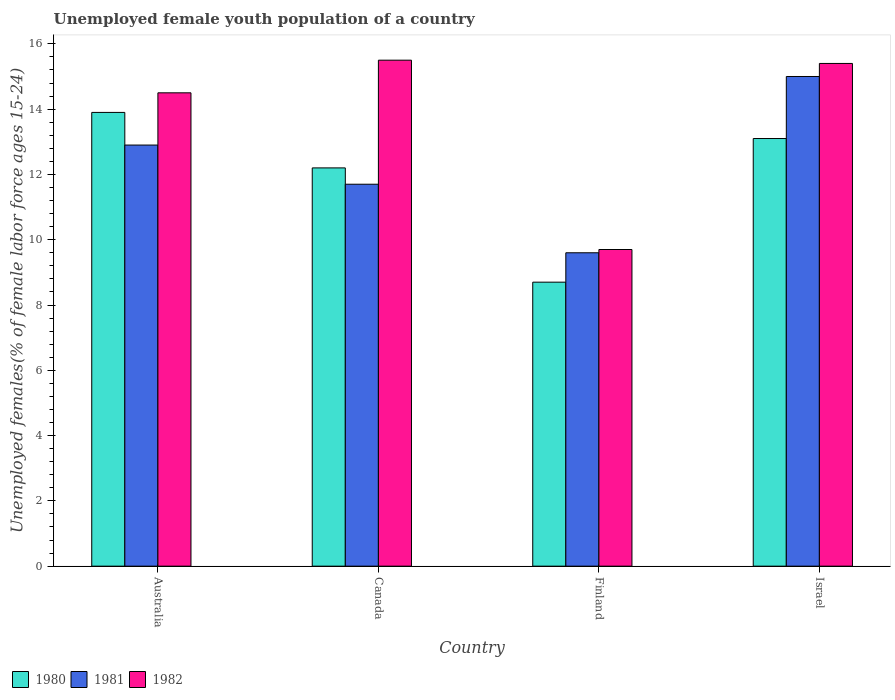How many different coloured bars are there?
Keep it short and to the point. 3. Are the number of bars per tick equal to the number of legend labels?
Provide a short and direct response. Yes. Are the number of bars on each tick of the X-axis equal?
Offer a terse response. Yes. How many bars are there on the 3rd tick from the right?
Keep it short and to the point. 3. Across all countries, what is the maximum percentage of unemployed female youth population in 1981?
Provide a short and direct response. 15. Across all countries, what is the minimum percentage of unemployed female youth population in 1981?
Provide a short and direct response. 9.6. In which country was the percentage of unemployed female youth population in 1981 maximum?
Provide a succinct answer. Israel. In which country was the percentage of unemployed female youth population in 1981 minimum?
Keep it short and to the point. Finland. What is the total percentage of unemployed female youth population in 1980 in the graph?
Offer a very short reply. 47.9. What is the difference between the percentage of unemployed female youth population in 1982 in Canada and that in Finland?
Offer a terse response. 5.8. What is the difference between the percentage of unemployed female youth population in 1980 in Israel and the percentage of unemployed female youth population in 1982 in Canada?
Keep it short and to the point. -2.4. What is the average percentage of unemployed female youth population in 1981 per country?
Keep it short and to the point. 12.3. What is the difference between the percentage of unemployed female youth population of/in 1980 and percentage of unemployed female youth population of/in 1981 in Finland?
Offer a very short reply. -0.9. In how many countries, is the percentage of unemployed female youth population in 1982 greater than 3.2 %?
Provide a succinct answer. 4. What is the ratio of the percentage of unemployed female youth population in 1981 in Finland to that in Israel?
Your answer should be compact. 0.64. What is the difference between the highest and the second highest percentage of unemployed female youth population in 1980?
Ensure brevity in your answer.  0.9. What is the difference between the highest and the lowest percentage of unemployed female youth population in 1981?
Offer a terse response. 5.4. What does the 2nd bar from the left in Canada represents?
Offer a very short reply. 1981. Is it the case that in every country, the sum of the percentage of unemployed female youth population in 1981 and percentage of unemployed female youth population in 1980 is greater than the percentage of unemployed female youth population in 1982?
Offer a terse response. Yes. How many countries are there in the graph?
Provide a succinct answer. 4. What is the difference between two consecutive major ticks on the Y-axis?
Offer a very short reply. 2. Does the graph contain grids?
Offer a very short reply. No. Where does the legend appear in the graph?
Your response must be concise. Bottom left. What is the title of the graph?
Give a very brief answer. Unemployed female youth population of a country. Does "1975" appear as one of the legend labels in the graph?
Give a very brief answer. No. What is the label or title of the X-axis?
Offer a very short reply. Country. What is the label or title of the Y-axis?
Give a very brief answer. Unemployed females(% of female labor force ages 15-24). What is the Unemployed females(% of female labor force ages 15-24) in 1980 in Australia?
Your answer should be very brief. 13.9. What is the Unemployed females(% of female labor force ages 15-24) in 1981 in Australia?
Give a very brief answer. 12.9. What is the Unemployed females(% of female labor force ages 15-24) of 1980 in Canada?
Give a very brief answer. 12.2. What is the Unemployed females(% of female labor force ages 15-24) of 1981 in Canada?
Your answer should be compact. 11.7. What is the Unemployed females(% of female labor force ages 15-24) of 1980 in Finland?
Offer a terse response. 8.7. What is the Unemployed females(% of female labor force ages 15-24) of 1981 in Finland?
Ensure brevity in your answer.  9.6. What is the Unemployed females(% of female labor force ages 15-24) of 1982 in Finland?
Keep it short and to the point. 9.7. What is the Unemployed females(% of female labor force ages 15-24) in 1980 in Israel?
Give a very brief answer. 13.1. What is the Unemployed females(% of female labor force ages 15-24) of 1981 in Israel?
Your answer should be compact. 15. What is the Unemployed females(% of female labor force ages 15-24) of 1982 in Israel?
Ensure brevity in your answer.  15.4. Across all countries, what is the maximum Unemployed females(% of female labor force ages 15-24) of 1980?
Provide a short and direct response. 13.9. Across all countries, what is the minimum Unemployed females(% of female labor force ages 15-24) in 1980?
Your answer should be very brief. 8.7. Across all countries, what is the minimum Unemployed females(% of female labor force ages 15-24) of 1981?
Provide a succinct answer. 9.6. Across all countries, what is the minimum Unemployed females(% of female labor force ages 15-24) in 1982?
Your answer should be very brief. 9.7. What is the total Unemployed females(% of female labor force ages 15-24) of 1980 in the graph?
Your answer should be very brief. 47.9. What is the total Unemployed females(% of female labor force ages 15-24) of 1981 in the graph?
Your answer should be compact. 49.2. What is the total Unemployed females(% of female labor force ages 15-24) in 1982 in the graph?
Your response must be concise. 55.1. What is the difference between the Unemployed females(% of female labor force ages 15-24) in 1980 in Australia and that in Canada?
Your answer should be very brief. 1.7. What is the difference between the Unemployed females(% of female labor force ages 15-24) in 1981 in Australia and that in Finland?
Offer a terse response. 3.3. What is the difference between the Unemployed females(% of female labor force ages 15-24) in 1982 in Australia and that in Israel?
Provide a short and direct response. -0.9. What is the difference between the Unemployed females(% of female labor force ages 15-24) of 1980 in Canada and that in Finland?
Offer a very short reply. 3.5. What is the difference between the Unemployed females(% of female labor force ages 15-24) of 1981 in Canada and that in Israel?
Your answer should be very brief. -3.3. What is the difference between the Unemployed females(% of female labor force ages 15-24) of 1982 in Canada and that in Israel?
Keep it short and to the point. 0.1. What is the difference between the Unemployed females(% of female labor force ages 15-24) in 1980 in Australia and the Unemployed females(% of female labor force ages 15-24) in 1981 in Canada?
Offer a very short reply. 2.2. What is the difference between the Unemployed females(% of female labor force ages 15-24) in 1981 in Australia and the Unemployed females(% of female labor force ages 15-24) in 1982 in Canada?
Provide a succinct answer. -2.6. What is the difference between the Unemployed females(% of female labor force ages 15-24) in 1980 in Australia and the Unemployed females(% of female labor force ages 15-24) in 1981 in Finland?
Offer a very short reply. 4.3. What is the difference between the Unemployed females(% of female labor force ages 15-24) in 1980 in Australia and the Unemployed females(% of female labor force ages 15-24) in 1982 in Finland?
Offer a terse response. 4.2. What is the difference between the Unemployed females(% of female labor force ages 15-24) of 1980 in Australia and the Unemployed females(% of female labor force ages 15-24) of 1982 in Israel?
Keep it short and to the point. -1.5. What is the difference between the Unemployed females(% of female labor force ages 15-24) of 1981 in Australia and the Unemployed females(% of female labor force ages 15-24) of 1982 in Israel?
Your response must be concise. -2.5. What is the difference between the Unemployed females(% of female labor force ages 15-24) in 1980 in Canada and the Unemployed females(% of female labor force ages 15-24) in 1982 in Finland?
Keep it short and to the point. 2.5. What is the difference between the Unemployed females(% of female labor force ages 15-24) in 1980 in Canada and the Unemployed females(% of female labor force ages 15-24) in 1981 in Israel?
Ensure brevity in your answer.  -2.8. What is the difference between the Unemployed females(% of female labor force ages 15-24) in 1981 in Canada and the Unemployed females(% of female labor force ages 15-24) in 1982 in Israel?
Keep it short and to the point. -3.7. What is the difference between the Unemployed females(% of female labor force ages 15-24) in 1980 in Finland and the Unemployed females(% of female labor force ages 15-24) in 1982 in Israel?
Your answer should be very brief. -6.7. What is the average Unemployed females(% of female labor force ages 15-24) of 1980 per country?
Your response must be concise. 11.97. What is the average Unemployed females(% of female labor force ages 15-24) of 1982 per country?
Provide a succinct answer. 13.78. What is the difference between the Unemployed females(% of female labor force ages 15-24) of 1980 and Unemployed females(% of female labor force ages 15-24) of 1982 in Australia?
Provide a succinct answer. -0.6. What is the difference between the Unemployed females(% of female labor force ages 15-24) of 1981 and Unemployed females(% of female labor force ages 15-24) of 1982 in Australia?
Your response must be concise. -1.6. What is the difference between the Unemployed females(% of female labor force ages 15-24) in 1981 and Unemployed females(% of female labor force ages 15-24) in 1982 in Canada?
Your response must be concise. -3.8. What is the difference between the Unemployed females(% of female labor force ages 15-24) in 1980 and Unemployed females(% of female labor force ages 15-24) in 1982 in Israel?
Your response must be concise. -2.3. What is the ratio of the Unemployed females(% of female labor force ages 15-24) in 1980 in Australia to that in Canada?
Your answer should be compact. 1.14. What is the ratio of the Unemployed females(% of female labor force ages 15-24) of 1981 in Australia to that in Canada?
Ensure brevity in your answer.  1.1. What is the ratio of the Unemployed females(% of female labor force ages 15-24) in 1982 in Australia to that in Canada?
Give a very brief answer. 0.94. What is the ratio of the Unemployed females(% of female labor force ages 15-24) of 1980 in Australia to that in Finland?
Provide a short and direct response. 1.6. What is the ratio of the Unemployed females(% of female labor force ages 15-24) in 1981 in Australia to that in Finland?
Keep it short and to the point. 1.34. What is the ratio of the Unemployed females(% of female labor force ages 15-24) of 1982 in Australia to that in Finland?
Keep it short and to the point. 1.49. What is the ratio of the Unemployed females(% of female labor force ages 15-24) in 1980 in Australia to that in Israel?
Your response must be concise. 1.06. What is the ratio of the Unemployed females(% of female labor force ages 15-24) in 1981 in Australia to that in Israel?
Keep it short and to the point. 0.86. What is the ratio of the Unemployed females(% of female labor force ages 15-24) of 1982 in Australia to that in Israel?
Ensure brevity in your answer.  0.94. What is the ratio of the Unemployed females(% of female labor force ages 15-24) in 1980 in Canada to that in Finland?
Provide a succinct answer. 1.4. What is the ratio of the Unemployed females(% of female labor force ages 15-24) in 1981 in Canada to that in Finland?
Your answer should be very brief. 1.22. What is the ratio of the Unemployed females(% of female labor force ages 15-24) in 1982 in Canada to that in Finland?
Your answer should be compact. 1.6. What is the ratio of the Unemployed females(% of female labor force ages 15-24) in 1980 in Canada to that in Israel?
Offer a terse response. 0.93. What is the ratio of the Unemployed females(% of female labor force ages 15-24) in 1981 in Canada to that in Israel?
Offer a terse response. 0.78. What is the ratio of the Unemployed females(% of female labor force ages 15-24) in 1982 in Canada to that in Israel?
Provide a succinct answer. 1.01. What is the ratio of the Unemployed females(% of female labor force ages 15-24) in 1980 in Finland to that in Israel?
Provide a succinct answer. 0.66. What is the ratio of the Unemployed females(% of female labor force ages 15-24) of 1981 in Finland to that in Israel?
Provide a short and direct response. 0.64. What is the ratio of the Unemployed females(% of female labor force ages 15-24) of 1982 in Finland to that in Israel?
Make the answer very short. 0.63. What is the difference between the highest and the second highest Unemployed females(% of female labor force ages 15-24) of 1982?
Your answer should be compact. 0.1. What is the difference between the highest and the lowest Unemployed females(% of female labor force ages 15-24) of 1980?
Your answer should be compact. 5.2. 